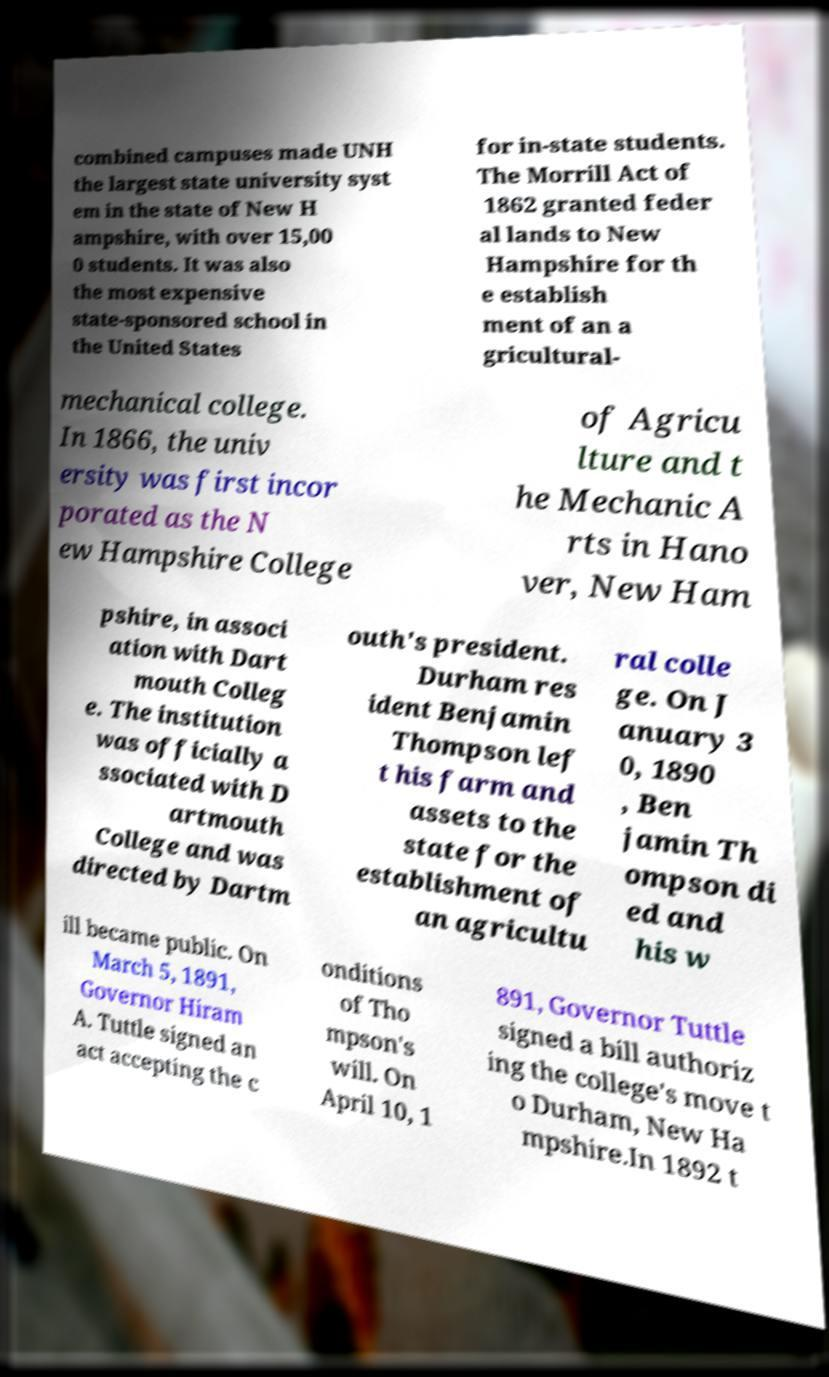Could you extract and type out the text from this image? combined campuses made UNH the largest state university syst em in the state of New H ampshire, with over 15,00 0 students. It was also the most expensive state-sponsored school in the United States for in-state students. The Morrill Act of 1862 granted feder al lands to New Hampshire for th e establish ment of an a gricultural- mechanical college. In 1866, the univ ersity was first incor porated as the N ew Hampshire College of Agricu lture and t he Mechanic A rts in Hano ver, New Ham pshire, in associ ation with Dart mouth Colleg e. The institution was officially a ssociated with D artmouth College and was directed by Dartm outh's president. Durham res ident Benjamin Thompson lef t his farm and assets to the state for the establishment of an agricultu ral colle ge. On J anuary 3 0, 1890 , Ben jamin Th ompson di ed and his w ill became public. On March 5, 1891, Governor Hiram A. Tuttle signed an act accepting the c onditions of Tho mpson's will. On April 10, 1 891, Governor Tuttle signed a bill authoriz ing the college's move t o Durham, New Ha mpshire.In 1892 t 